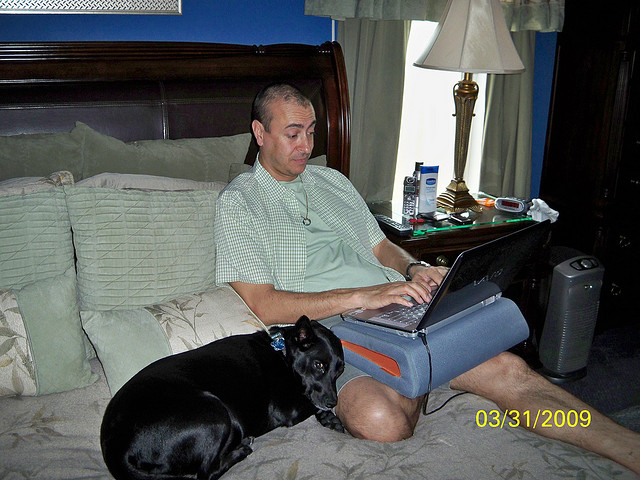<image>Why does the man look so stunned? It is unknown why the man looks so stunned. It could be due to a surprising email, shocking online conversation or because of bad news. Why does the man look so stunned? I don't know why the man looks so stunned. It could be because of an email he saw, something on the computer, an online conversation, his bank balance, or bad news. 